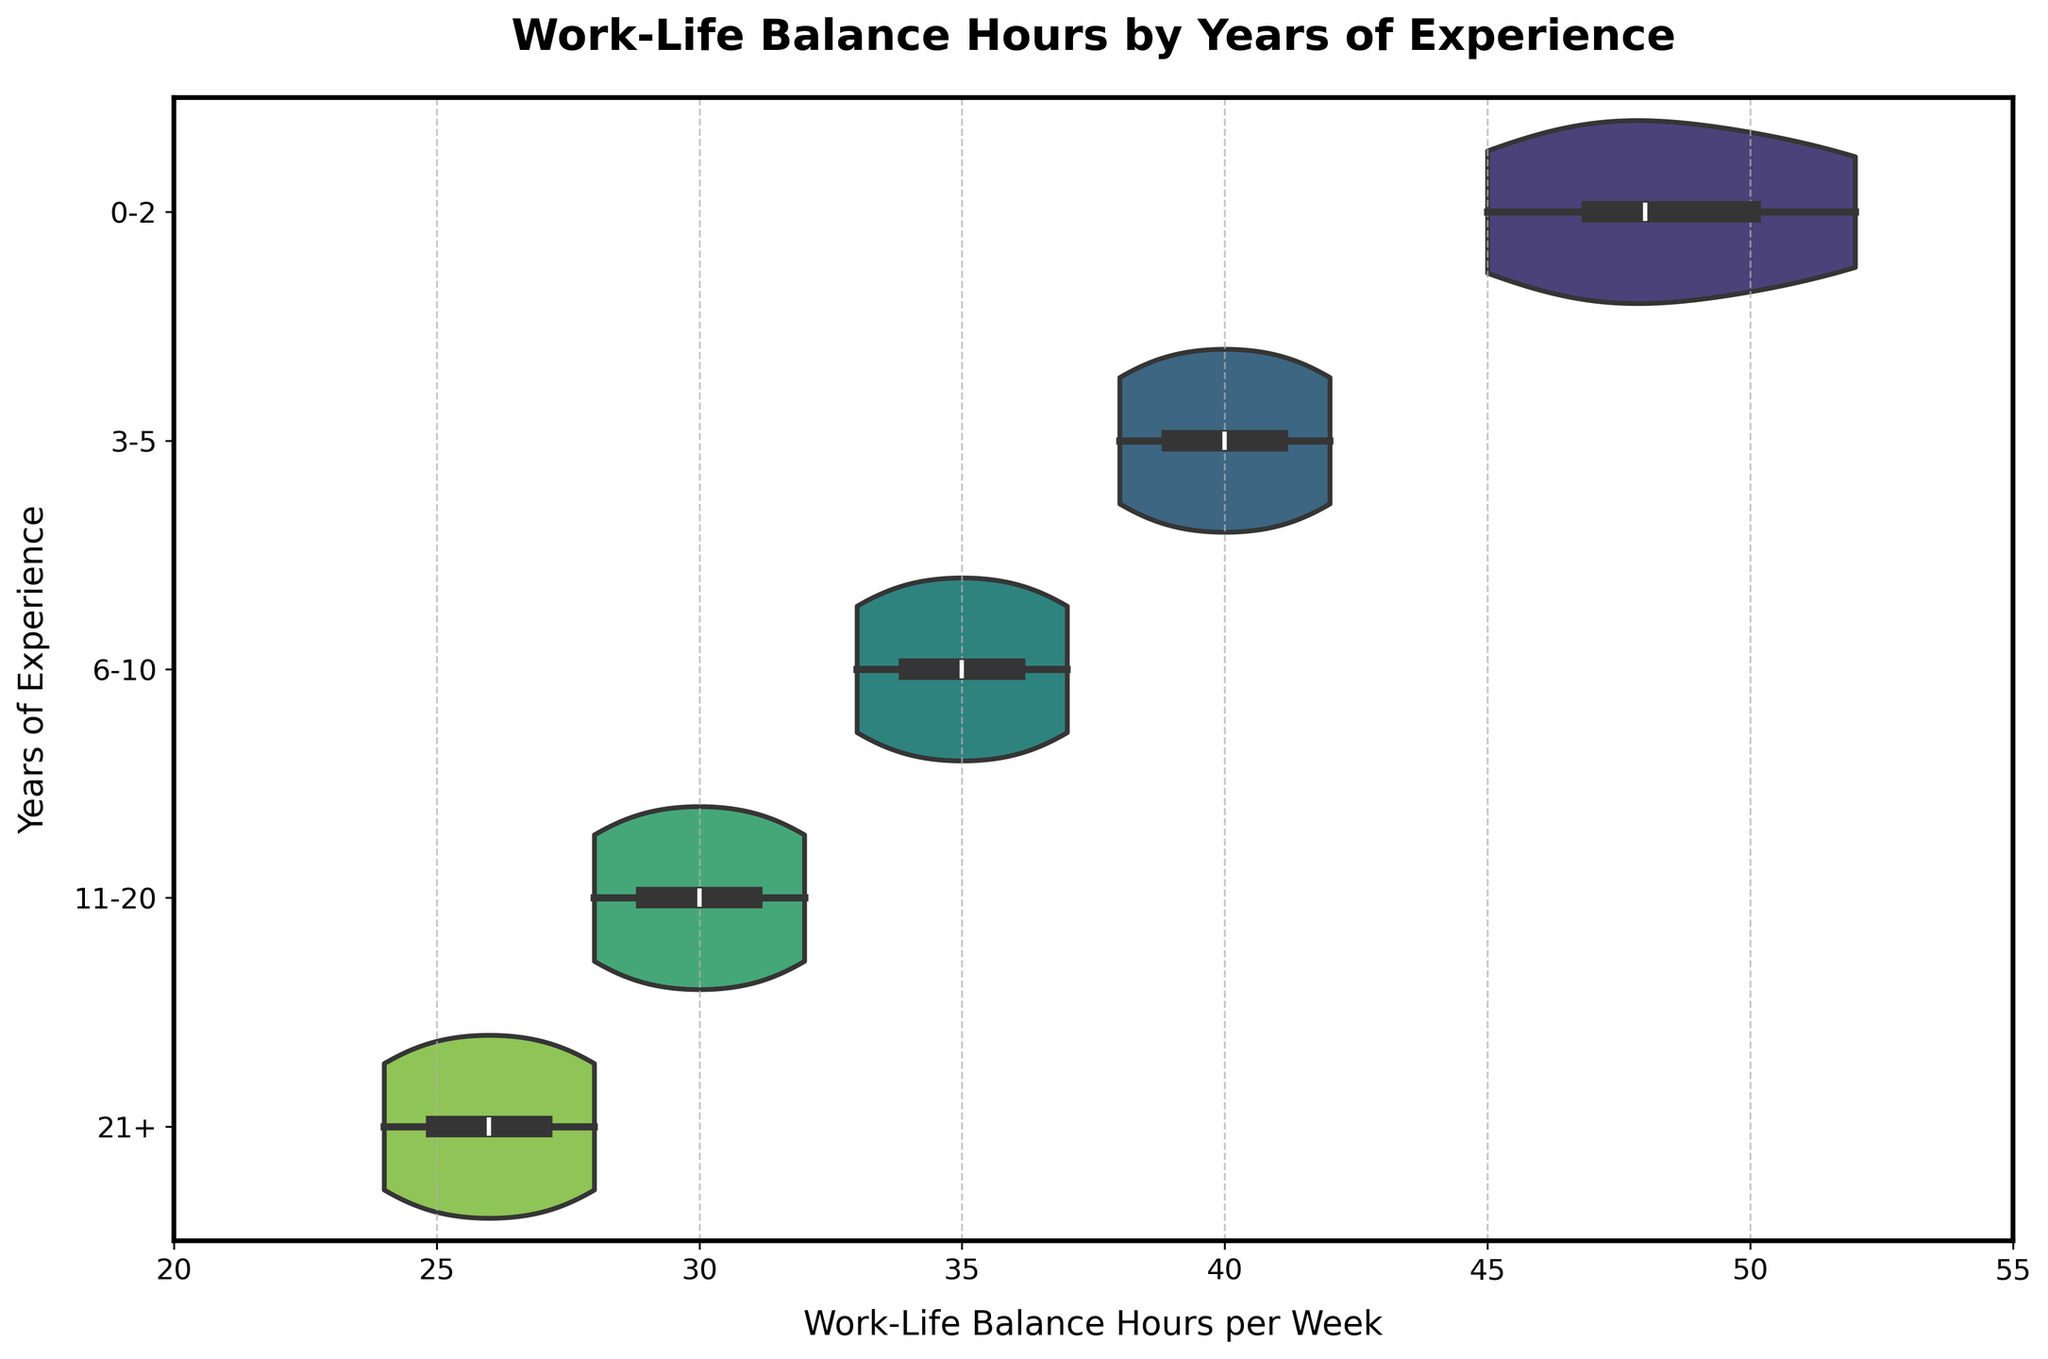What is the title of the figure? The title can be found at the top of the figure. It reads "Work-Life Balance Hours by Years of Experience".
Answer: Work-Life Balance Hours by Years of Experience Which group has the highest median Work-Life Balance hours per week? The group with the highest median is the one with the thickest section in the middle of the violin plot. Observing the medians, "0-2" years of experience group has the highest median Work-Life Balance hours per week.
Answer: 0-2 How do Work-Life Balance hours per week trend as years of experience increase? By observing the violin plots from top to bottom, there is a visible decreasing trend in Work-Life Balance hours per week.
Answer: Decrease What is the approximate range of Work-Life Balance hours per week for attorneys with 0-2 years of experience? By looking at the width of the violin plot for "0-2" years, we can see it spans from around 45 to 52 hours.
Answer: 45 to 52 hours Which group has the most variability in Work-Life Balance hours per week? The group with the widest range in the violin plot indicates more variability. The "0-2" years of experience group shows the widest spread.
Answer: 0-2 Do any of the experience groups show a work-life balance of less than 30 hours per week? Observing the x-axis limits and the spread of the violin plots, none of the groups have a range that falls below 30 hours per week.
Answer: No Which group has the lowest median Work-Life Balance hours per week? The group with the smallest section in the middle of the violin plot indicates the lowest median. The "21+" years of experience group displays the lowest median hours.
Answer: 21+ What can you infer about the work-life balance of attorneys with 11-20 years of experience compared to those with 6-10 years? By comparing the violin plots of the two groups, the "11-20" years group has a lower median and a generally lower range of Work-Life Balance hours when compared to the "6-10" years group.
Answer: 11-20 years have a lower work-life balance Between which two consecutive groups is the largest difference in median Work-Life Balance hours per week? By identifying the medians in each group and calculating the differences, the largest drop is seen between "0-2" years and "3-5" years.
Answer: 0-2 and 3-5 What Work-Life Balance hours per week range do practicing attorneys with 21+ years of experience fall into? For the "21+" years group, the violin plot ranges from about 24 to 28 hours per week.
Answer: 24 to 28 hours 